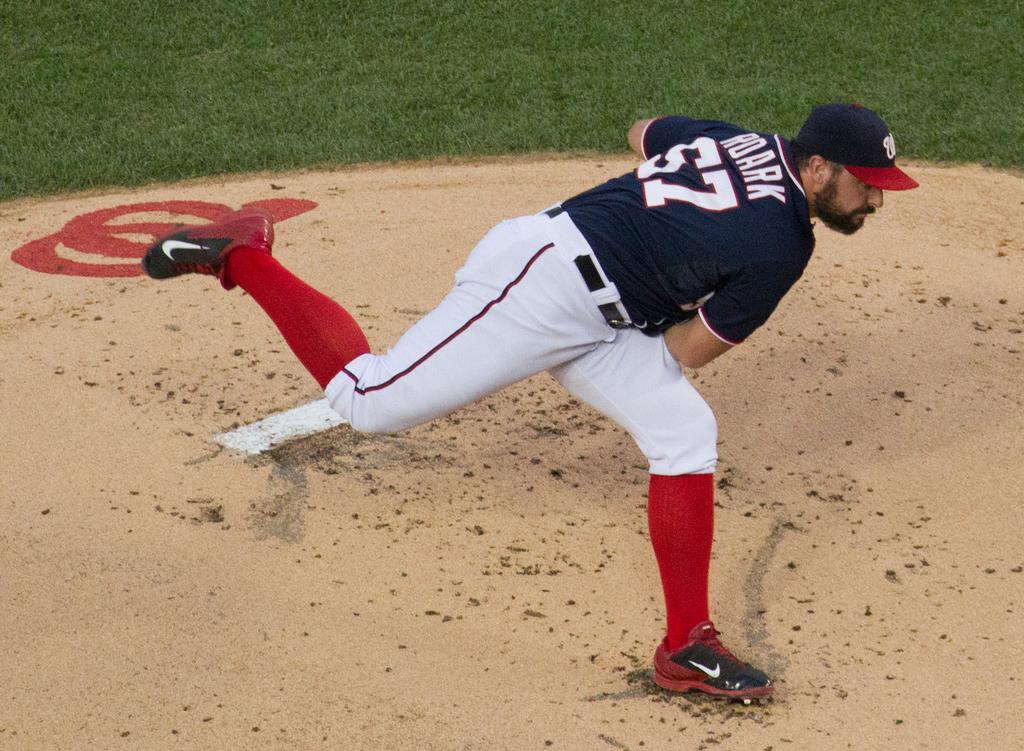<image>
Describe the image concisely. Number 57 ball player just threw a pitch from the mound. 